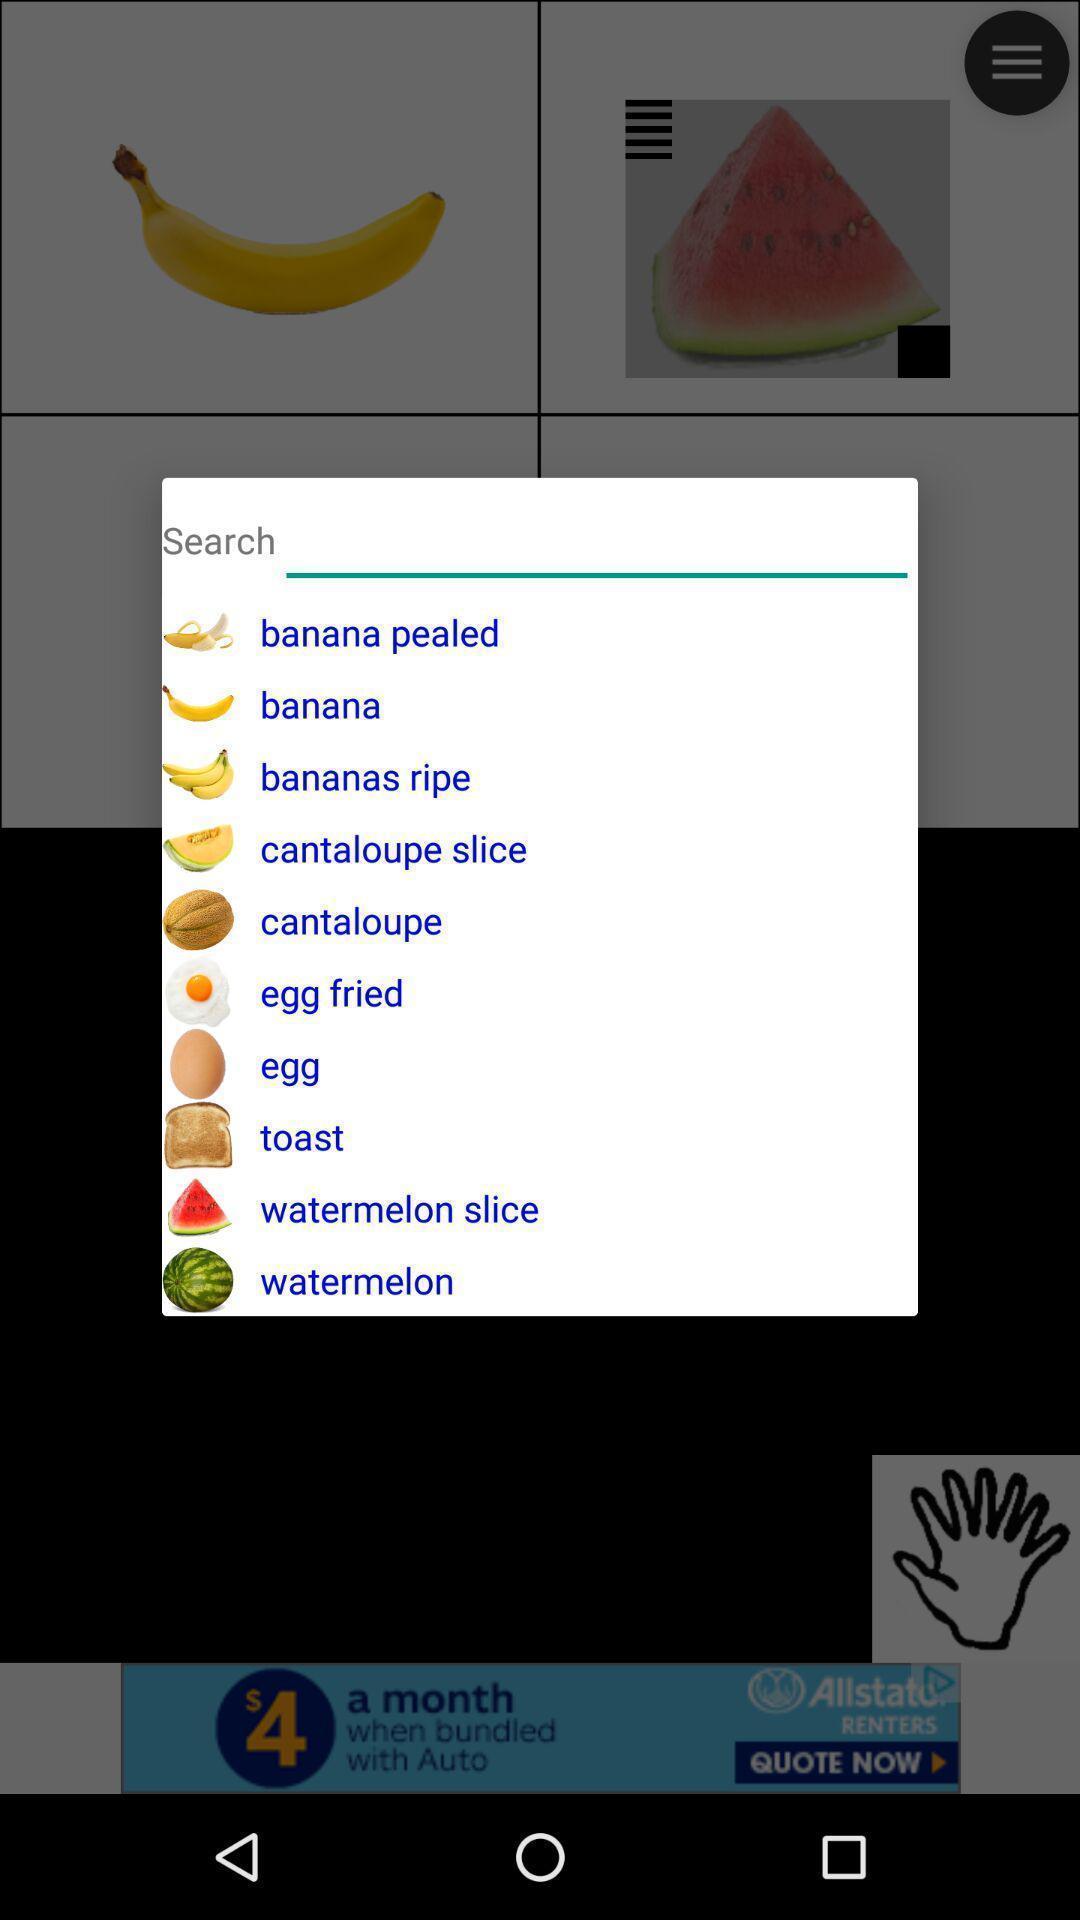Provide a detailed account of this screenshot. Pop-up to search for desired food. 